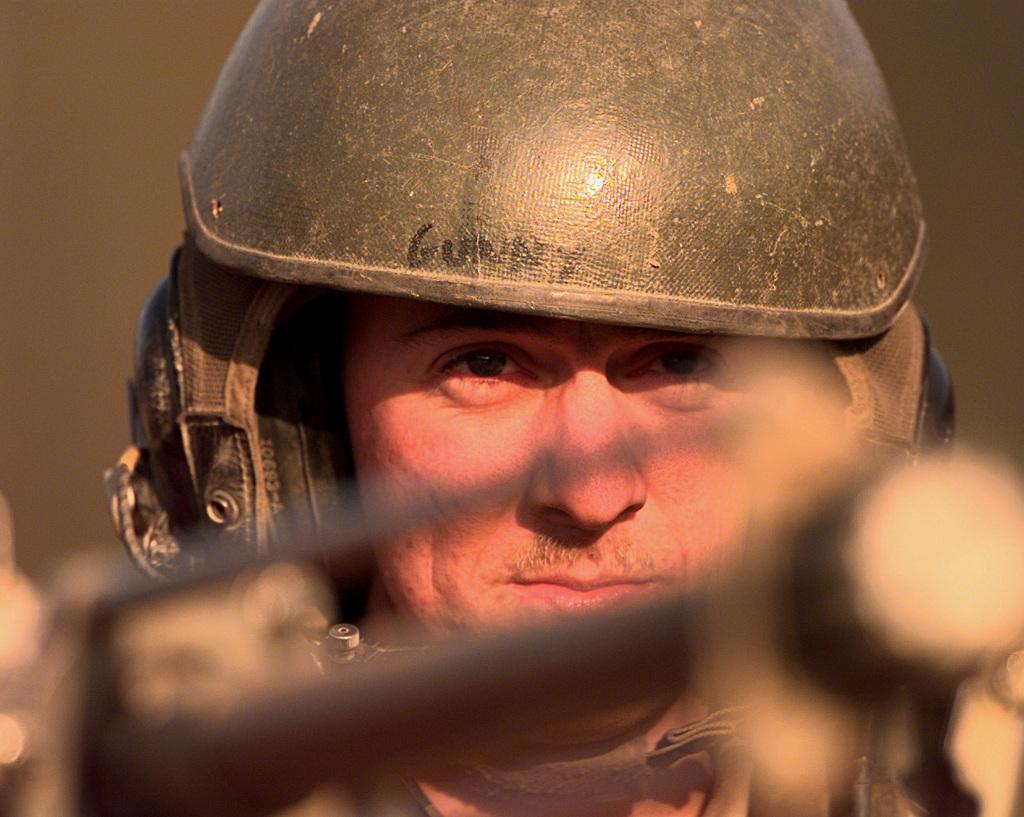How would you summarize this image in a sentence or two? In this image, we can see a person wearing a helmet, at the bottom, we can see a weapon. 